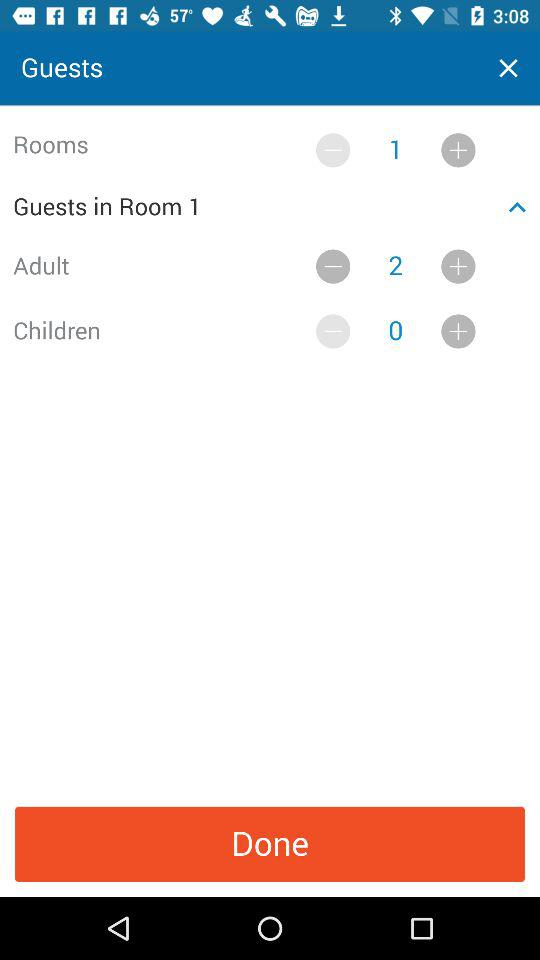How many rooms are there?
Answer the question using a single word or phrase. 1 